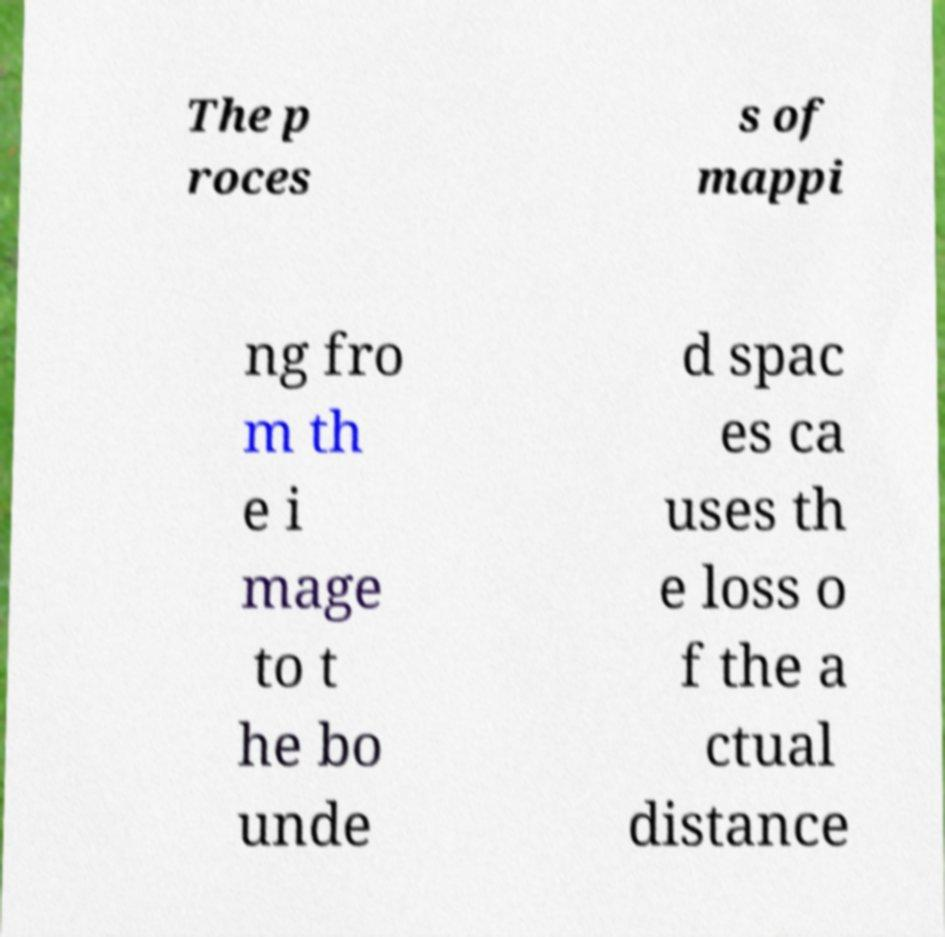Can you read and provide the text displayed in the image?This photo seems to have some interesting text. Can you extract and type it out for me? The p roces s of mappi ng fro m th e i mage to t he bo unde d spac es ca uses th e loss o f the a ctual distance 